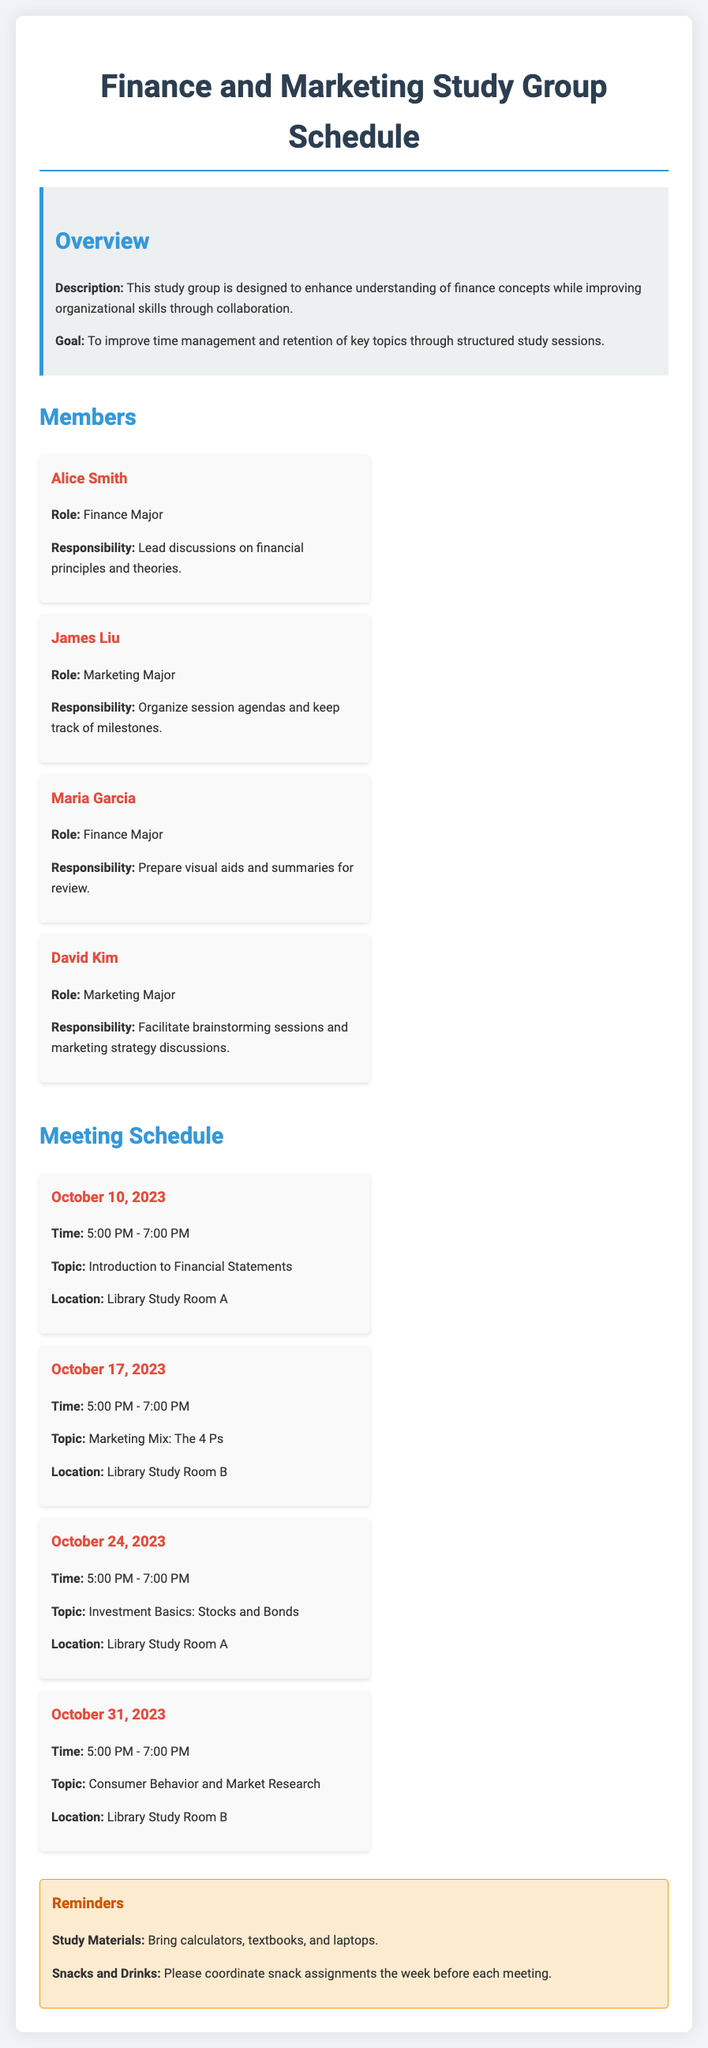What is the role of Alice Smith? Alice Smith is a Finance Major whose responsibility is to lead discussions on financial principles and theories.
Answer: Lead discussions on financial principles and theories What is the date of the meeting covering the Marketing Mix? The meeting covering the Marketing Mix is scheduled for October 17, 2023.
Answer: October 17, 2023 What is the time duration of each study session? Each study session is scheduled to take place from 5:00 PM to 7:00 PM.
Answer: 5:00 PM - 7:00 PM Who is responsible for organizing session agendas? James Liu is responsible for organizing session agendas and keeping track of milestones.
Answer: James Liu What is the location for the meeting on Consumer Behavior and Market Research? The meeting on Consumer Behavior and Market Research will be held in Library Study Room B.
Answer: Library Study Room B How many members are in the study group? There are four members in the study group.
Answer: Four What is the goal of the study group? The goal of the study group is to improve time management and retention of key topics through structured study sessions.
Answer: Improve time management and retention of key topics What materials should members bring to the study sessions? Members are asked to bring calculators, textbooks, and laptops to the study sessions.
Answer: Calculators, textbooks, and laptops 